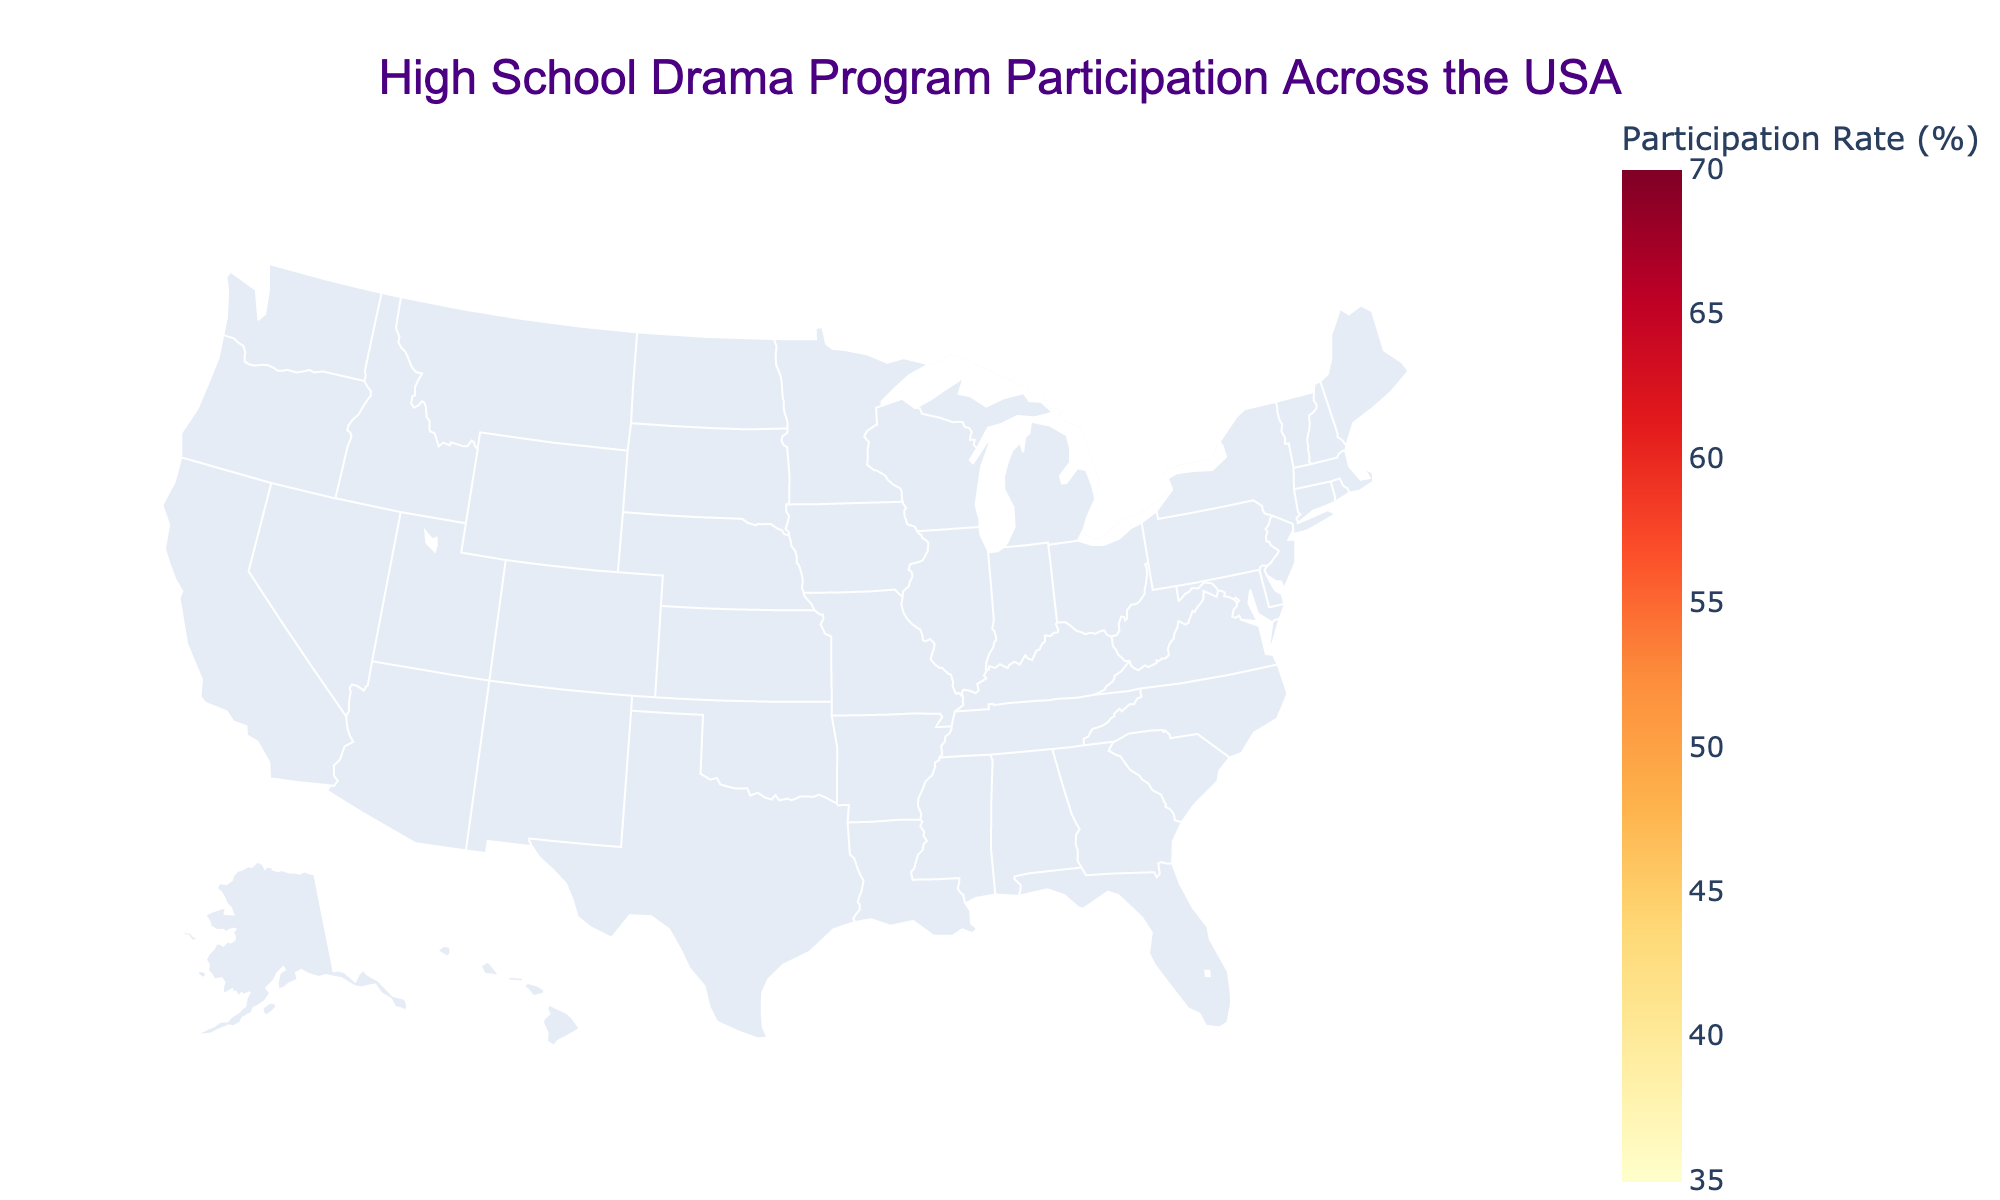What's the title of the map? The title is located at the top of the map, right in the center. It uses a larger font size and a distinct color for emphasis.
Answer: High School Drama Program Participation Across the USA Which state has the highest participation rate? Look for the state with the darkest shade of color on the map. According to the color key, the darkest shades represent higher participation rates.
Answer: New York How many schools in California have drama programs? The map includes hover data, where each state shows additional information when hovered over. Hover over California to find this data.
Answer: 1800 What is the average participation rate across all states represented? To find the average, sum the participation rates and divide by the number of states. Calculate: (68+62+55+52+50+48+45+58+53+47+40+59+51+46+43+41+49+52+38+37) / 20.
Answer: 50.3 Which state has a higher participation rate, Massachusetts or Texas? Compare the two states directly by observing their colors and corresponding shades on the map. Hover over each state to verify the exact rates.
Answer: Massachusetts What can be said about the participation rates in the Northern vs. Southern states? Observe the map's color patterns for states in the north (like New York and Pennsylvania) and the south (like Texas and Georgia). Compare the general shades and interpret.
Answer: Northern states generally have higher participation rates Identify two states with participation rates below 40%. Look for states with the lightest color shades on the map, as these represent lower participation rates.
Answer: Missouri and Tennessee Compare the distribution of drama programs between Ohio and Florida. Hover over both states to reveal the data about the number of schools with drama programs.
Answer: Ohio: 700, Florida: 800 If you were to focus on increasing participation rates, which region would benefit the most based on the current data? Analyze the region with generally lower participation rates by comparing color intensity geographically.
Answer: The Southern states What trend do you notice regarding states with the highest number of schools having drama programs? Look at states like California and Texas, which have the highest numbers. Determine if there's a correlation between many schools offering programs and participation rates.
Answer: States with many schools don't necessarily have the highest participation rates 